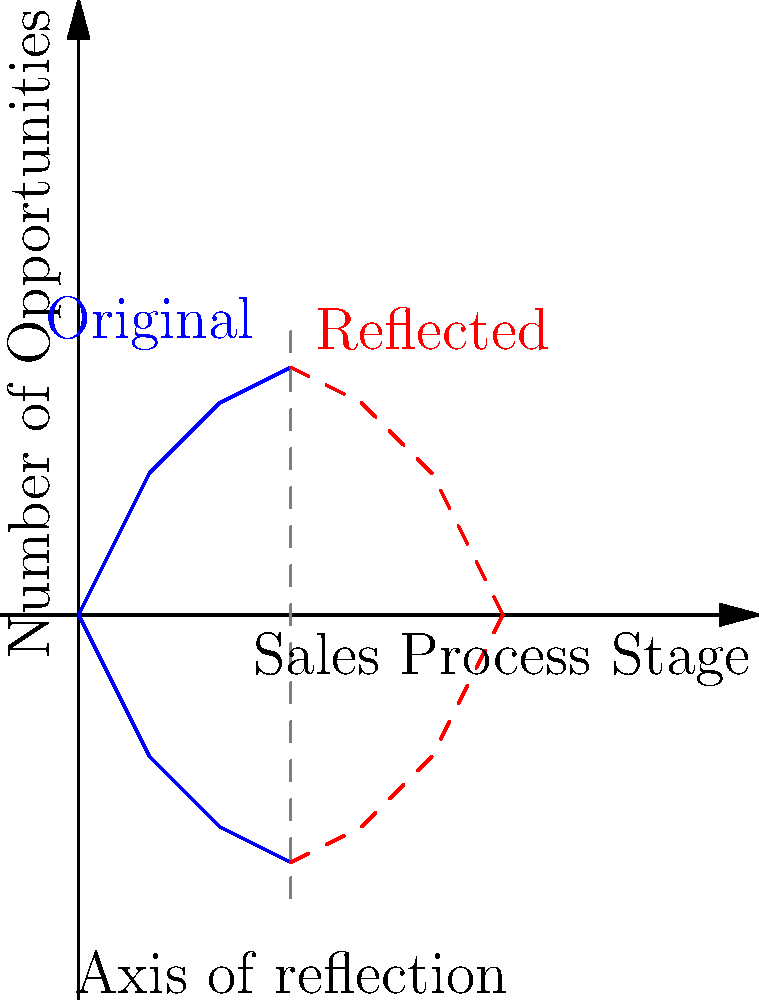In a Salesforce dashboard, you've created a sales pipeline funnel graph to visualize the opportunity stages. To compare this quarter's performance with the previous quarter, you need to reflect the graph across a vertical axis. If the rightmost point of the original funnel is at (3, 3.5), what will be the coordinates of the corresponding point in the reflected funnel? To solve this problem, we need to understand the principle of reflection across a vertical axis:

1. Identify the axis of reflection: In this case, it's the vertical line x = 3.

2. Understand the reflection principle: When reflecting a point (x, y) across the vertical line x = a, the reflected point will be (2a - x, y).

3. Apply the formula to our specific point:
   - Original point: (3, 3.5)
   - Axis of reflection: x = 3
   - Let's call the reflected point (x', y')
   
   x' = 2(3) - 3 = 6 - 3 = 3
   y' = 3.5 (y-coordinate remains unchanged in a vertical reflection)

4. Therefore, the reflected point will be (3, 3.5).

This means that the rightmost point of the original funnel and its reflection will coincide on the axis of reflection.
Answer: (3, 3.5) 